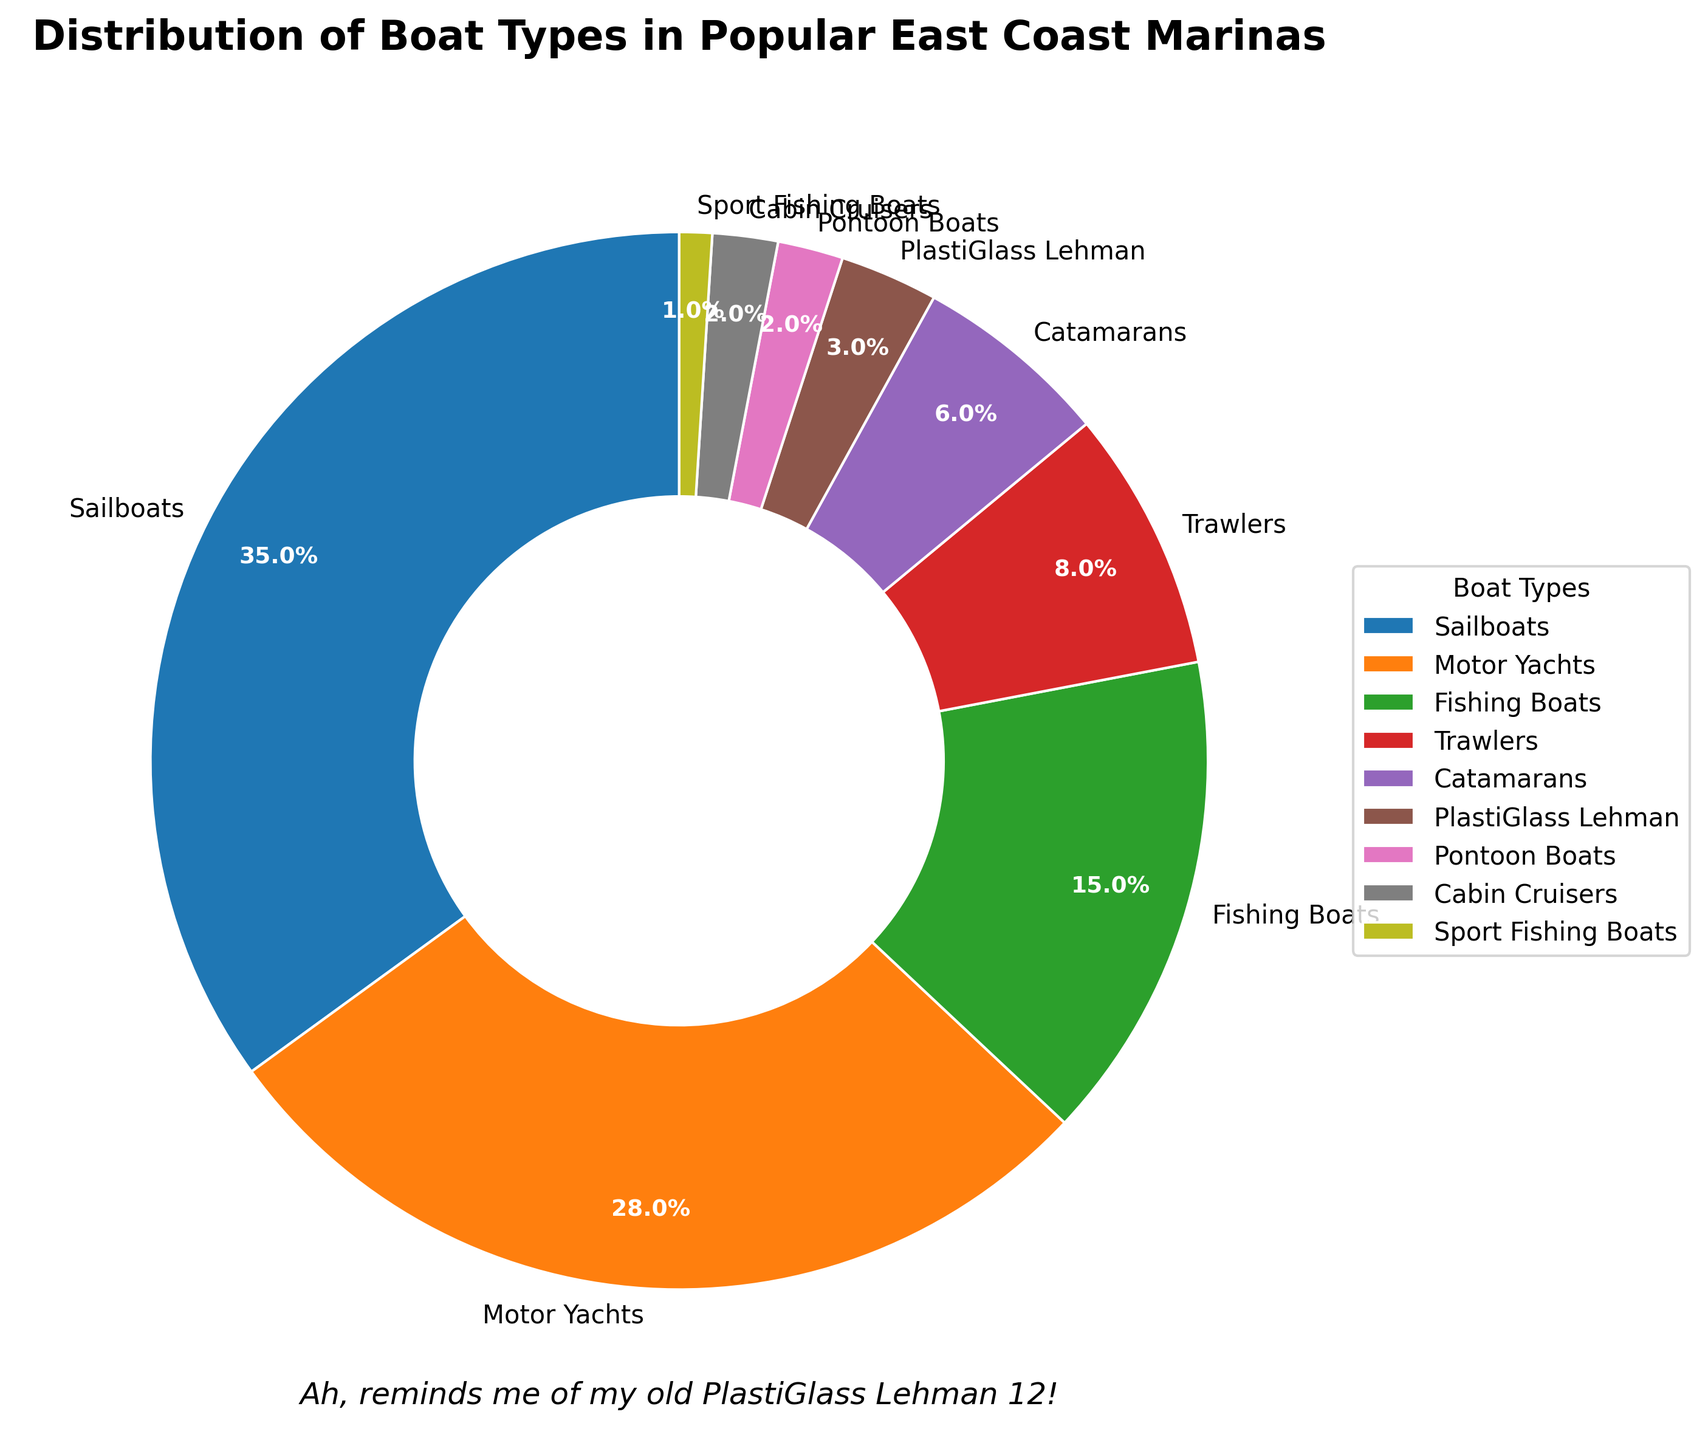How many boat types have a percentage higher than 20%? Sailboats have 35% and Motor Yachts have 28%. Since these are the only boat types with a percentage higher than 20%, there are two boat types in this category.
Answer: 2 What percentage of the boats are Fishing Boats or Trawlers? Fishing Boats have 15% and Trawlers have 8%. Adding these two percentages together gives a total of 15% + 8% = 23%.
Answer: 23% Which boat type has the smallest percentage in the distribution? Examining the chart, Sport Fishing Boats have the smallest percentage at 1%.
Answer: Sport Fishing Boats Are there more Sailboats or Motor Yachts in the marinas? According to the chart, Sailboats account for 35% while Motor Yachts account for 28%. This means there are more Sailboats.
Answer: Sailboats What is the combined percentage of sail-based boats (Sailboats and Catamarans)? Sailboats have 35% and Catamarans have 6%. Adding these two percentages together gives a total of 35% + 6% = 41%.
Answer: 41% Which boat is represented in my old PlastiGlass Lehman 12? The chart specifically includes the PlastiGlass Lehman boat type with a percentage of 3%.
Answer: PlastiGlass Lehman If the marinas want to increase the representation of Fishing Boats to 20%, by what percentage do they need to boost it? The current percentage of Fishing Boats is 15%. To increase this to 20%, the difference required would be 20% - 15% = 5%.
Answer: 5% Between Motor Yachts and Catamarans, which boat type accounts for a larger percentage of the distribution and by how much? Motor Yachts account for 28% and Catamarans account for 6%. The difference is 28% - 6% = 22%.
Answer: Motor Yachts Is the percentage of PlastiGlass Lehman boats lesser or greater than the combined percentage of Pontoon Boats and Cabin Cruisers? PlastiGlass Lehman boats represent 3%. Pontoon Boats and Cabin Cruisers together represent 2% + 2% = 4%. Since 3% is less than 4%, the percentage of PlastiGlass Lehman boats is lesser.
Answer: Lesser What is the difference in percentage between the most popular and the least popular boat type? The most popular boat type is Sailboats at 35%, and the least popular is Sport Fishing Boats at 1%. The difference is 35% - 1% = 34%.
Answer: 34% 